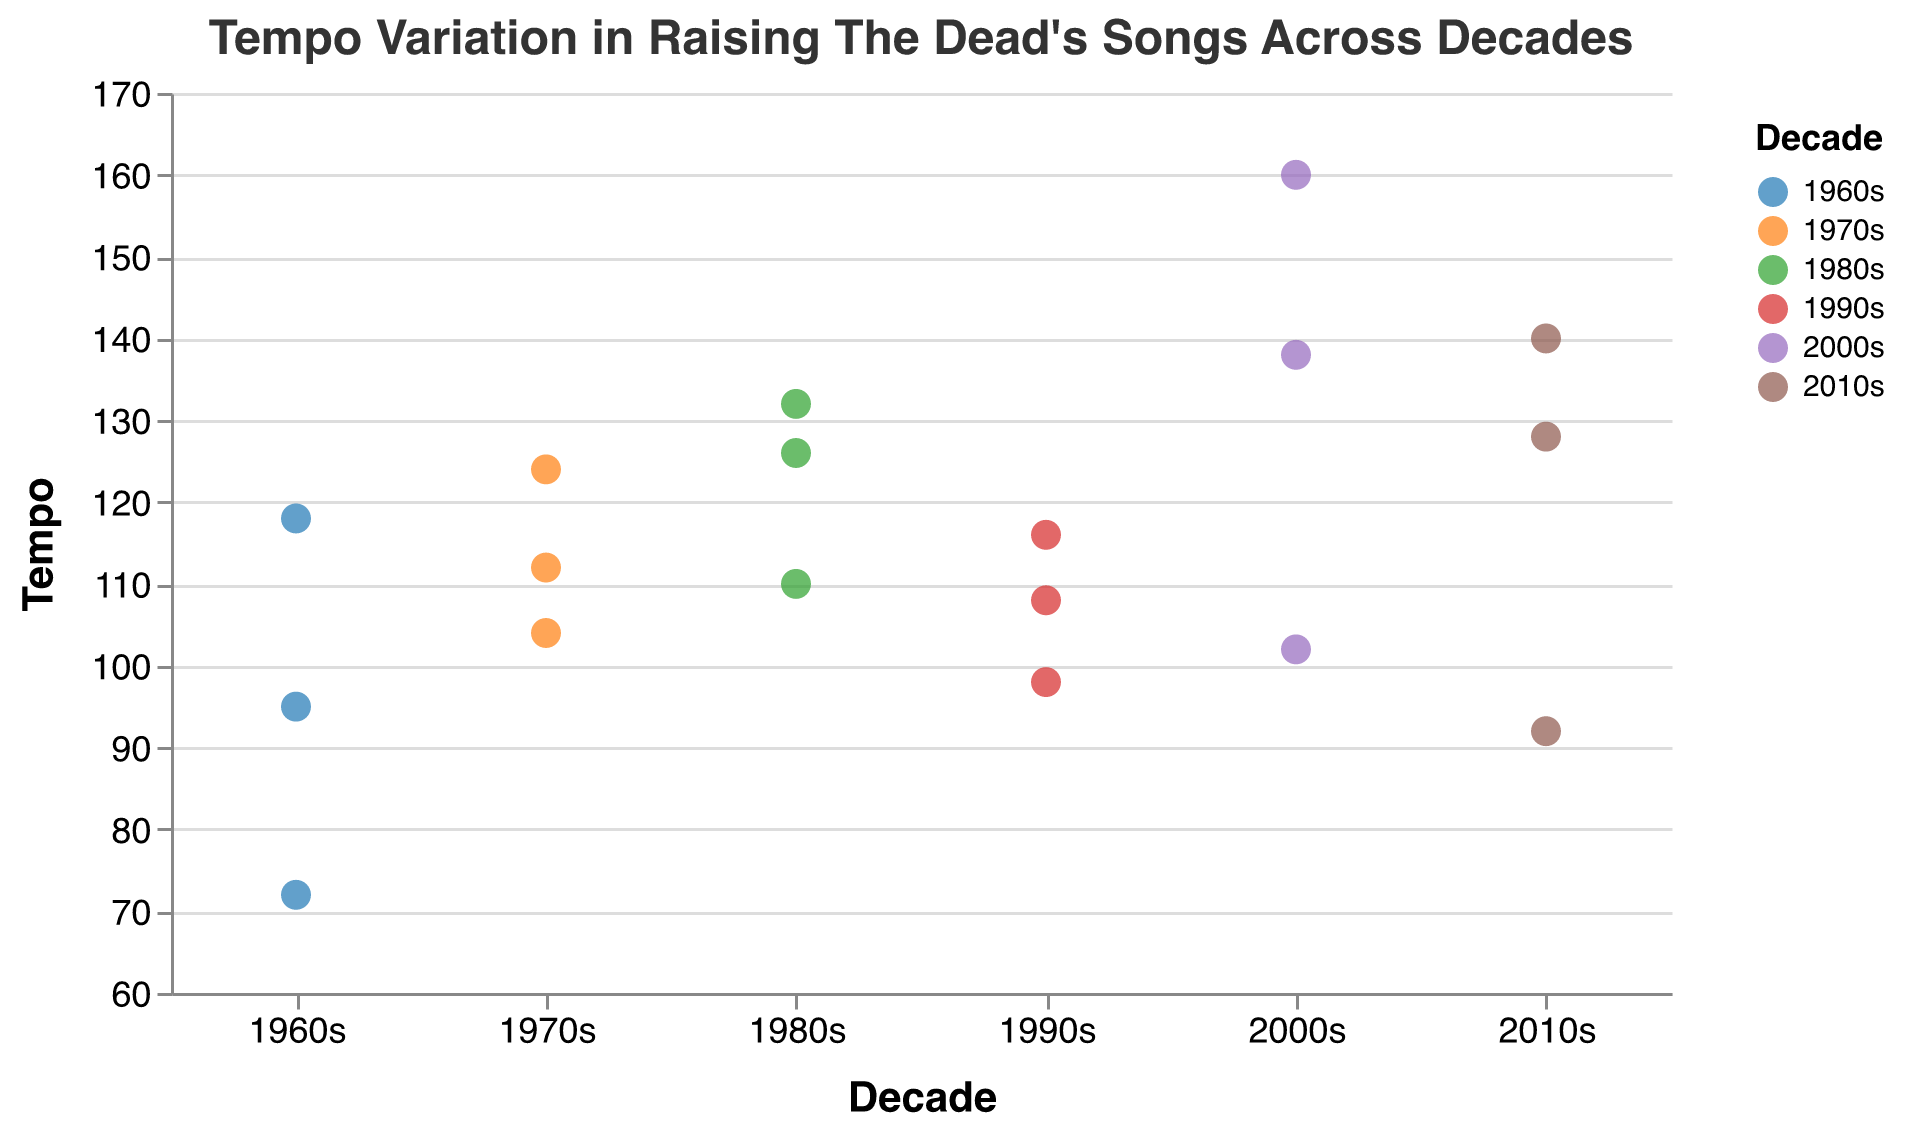What is the title of the figure? The title is prominent at the top of the figure and reads "Tempo Variation in Raising The Dead's Songs Across Decades".
Answer: Tempo Variation in Raising The Dead's Songs Across Decades How many songs are represented in the 1980s? By looking at the number of data points (dots) colored for the 1980s, we can count them.
Answer: 3 Which song has the highest tempo? The highest tempo will be the data point highest on the y-axis. By checking the tooltips of the highest points, we find "Pop Punk Energy" at 160 BPM.
Answer: Pop Punk Energy Between which two decades is the biggest difference in the average tempo? Calculate the average tempo for each decade and compare. The average for each decade: 1960s - 95, 1970s - 113.33, 1980s - 122.67, 1990s - 107.33, 2000s - 133.33, 2010s - 120. The biggest difference is between 2000s and 1960s at 133.33 - 95 = 38.33 BPM.
Answer: 2000s and 1960s What is the median tempo of songs in the 1990s? Sort the tempos of the 1990s and find the middle value. The tempos are 98, 108, 116; the middle value is 108.
Answer: 108 Which decade has the widest range of tempos? Find the range of tempos for each decade by calculating the difference between the maximum and minimum tempos within each decade. The ranges: 1960s(118-72 = 46), 1970s(124-104 = 20), 1980s(132-110 = 22), 1990s(116-98 = 18), 2000s(160-102 = 58), 2010s(140-92 = 48). The 2000s have the widest range of 58 BPM.
Answer: 2000s Is there a decade where all songs have tempos above 100 BPM? Check if all the data points for a decade are above 100 BPM. In the 1980s (110, 126, 132), all are above 100 BPM.
Answer: 1980s Which decade sees the highest average tempo in Raising The Dead's songs? Calculate the average tempo for each decade and compare. The averages are 1960s(95), 1970s(113.33), 1980s(122.67), 1990s(107.33), 2000s(133.33), 2010s(120). The 2000s have the highest average at 133.33 BPM.
Answer: 2000s What is the tempo of the song "Grunge Anthem"? Find the data point for "Grunge Anthem" and refer to its tempo value.
Answer: 98 BPM 